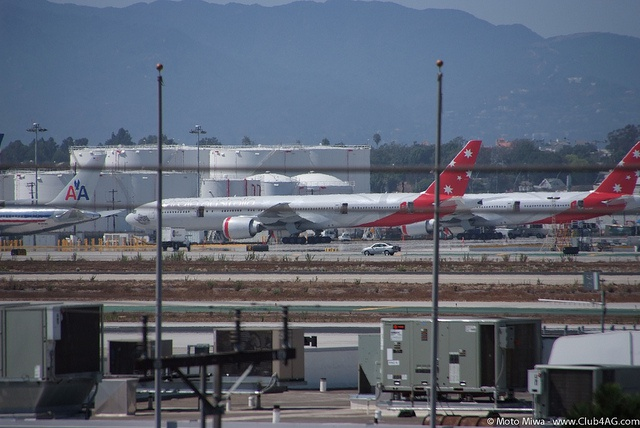Describe the objects in this image and their specific colors. I can see airplane in blue, gray, lightgray, and darkgray tones, airplane in blue, gray, maroon, darkgray, and lightgray tones, airplane in blue, gray, darkgray, and navy tones, truck in blue, darkgray, black, and gray tones, and car in blue, gray, black, and lightgray tones in this image. 